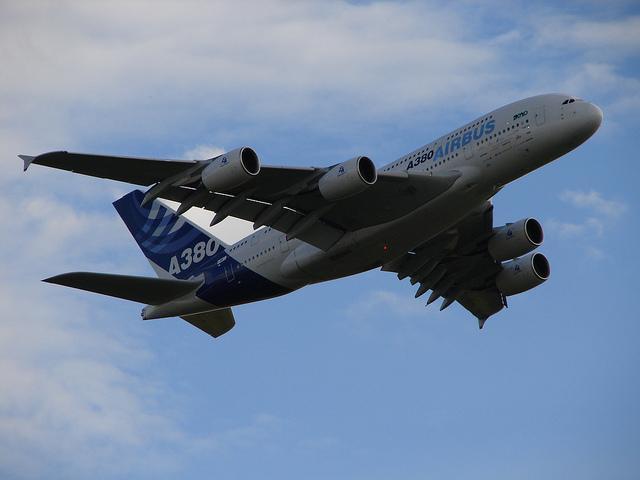How many engines does the plane have?
Give a very brief answer. 4. 